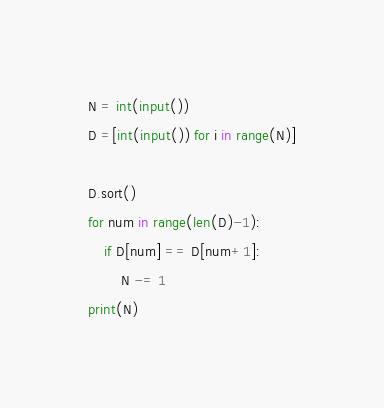<code> <loc_0><loc_0><loc_500><loc_500><_Python_>N = int(input())
D =[int(input()) for i in range(N)]

D.sort()
for num in range(len(D)-1):
    if D[num] == D[num+1]:
        N -= 1
print(N)
</code> 